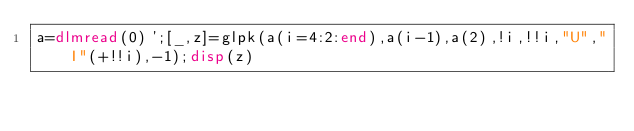Convert code to text. <code><loc_0><loc_0><loc_500><loc_500><_Octave_>a=dlmread(0)';[_,z]=glpk(a(i=4:2:end),a(i-1),a(2),!i,!!i,"U","I"(+!!i),-1);disp(z)</code> 